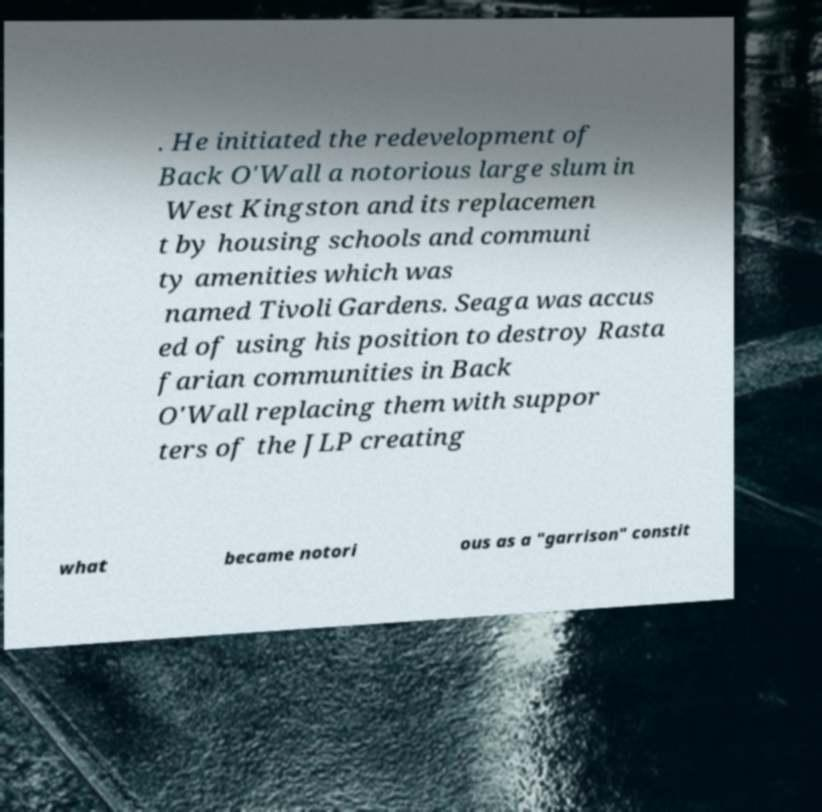Please identify and transcribe the text found in this image. . He initiated the redevelopment of Back O'Wall a notorious large slum in West Kingston and its replacemen t by housing schools and communi ty amenities which was named Tivoli Gardens. Seaga was accus ed of using his position to destroy Rasta farian communities in Back O'Wall replacing them with suppor ters of the JLP creating what became notori ous as a "garrison" constit 